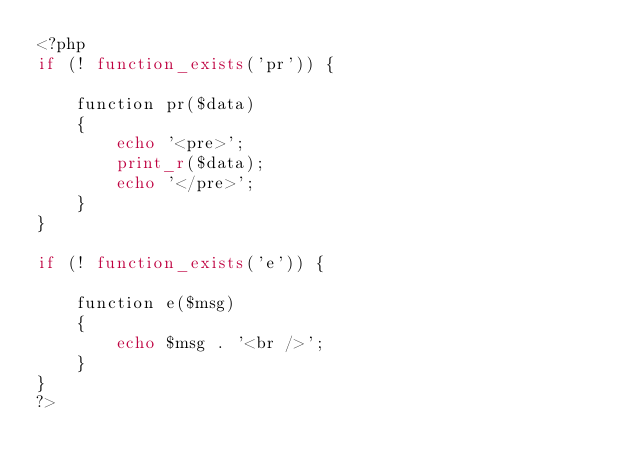<code> <loc_0><loc_0><loc_500><loc_500><_PHP_><?php
if (! function_exists('pr')) {

    function pr($data)
    {
        echo '<pre>';
        print_r($data);
        echo '</pre>';
    }
}

if (! function_exists('e')) {

    function e($msg)
    {
        echo $msg . '<br />';
    }
}
?></code> 